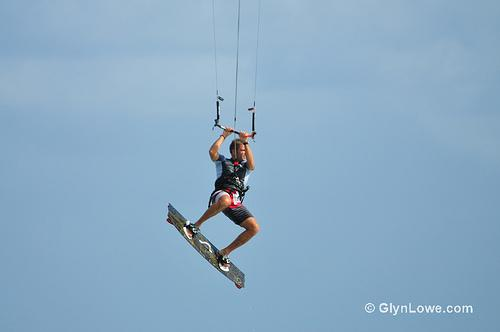Ask a friend to identify the central image of the picture without revealing any specifics. What details will you provide them? Look for a person wearing a black and red outfit, engaged in an adventurous and exciting airborne activity. Choose a significant detail from the image and elaborate on its importance in the overall scene. The man's grip on the bar is important because it signifies his control and determination while kiteboarding in the sky. For the visual entailment task, describe the relationship between the man and the sky elements in the image. The man is kiteboarding in the air, surrounded by a blue clear sky with white clouds. Identify the position of the man's legs and arms in the image. The man's legs are bent with his feet placed on a board, and his arms are bent as he holds on to a bar. Relate this image to an experience you or someone else might have had during a vacation. During a vacation at a beach resort, I saw someone kiteboarding above the water, wearing a similar outfit, surrounded by a clear blue sky. Mention the color of the sky and the presence of any natural elements in it. The sky is blue and clear with white clouds scattered against it. Compose a poem stanza inspired by the image. Man rode the winds with pure delight. Name the marketing campaign that can be created using this image, and describe its theme. "Ride the Skies with Adventure" - A campaign promoting adrenaline-fueled water sports and harness-based activities. Explain how the man is being lifted and transported in the image. The man is being lifted and transported by a kite attached to him, while kiteboarding. What is the man in the image wearing and what activity is he engaged in? The man is wearing a black and red outfit, and he is engaged in kiteboarding above water. 